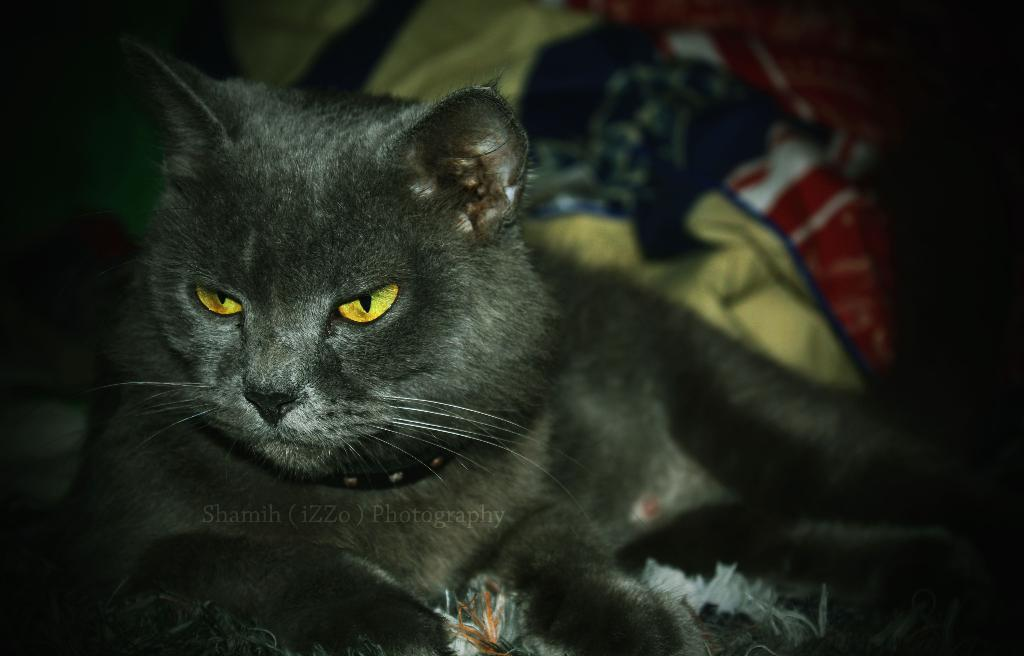What type of animal is in the image? There is a cat in the image. Can you describe the cat's appearance? The cat has brown and white colors. What else can be seen in the background of the image? There are clothes in the background of the image. What colors are the clothes? The clothes have red, blue, and cream colors. How many pickles are on the cat's head in the image? There are no pickles present in the image, as it features a cat with brown and white colors and clothes in the background. 